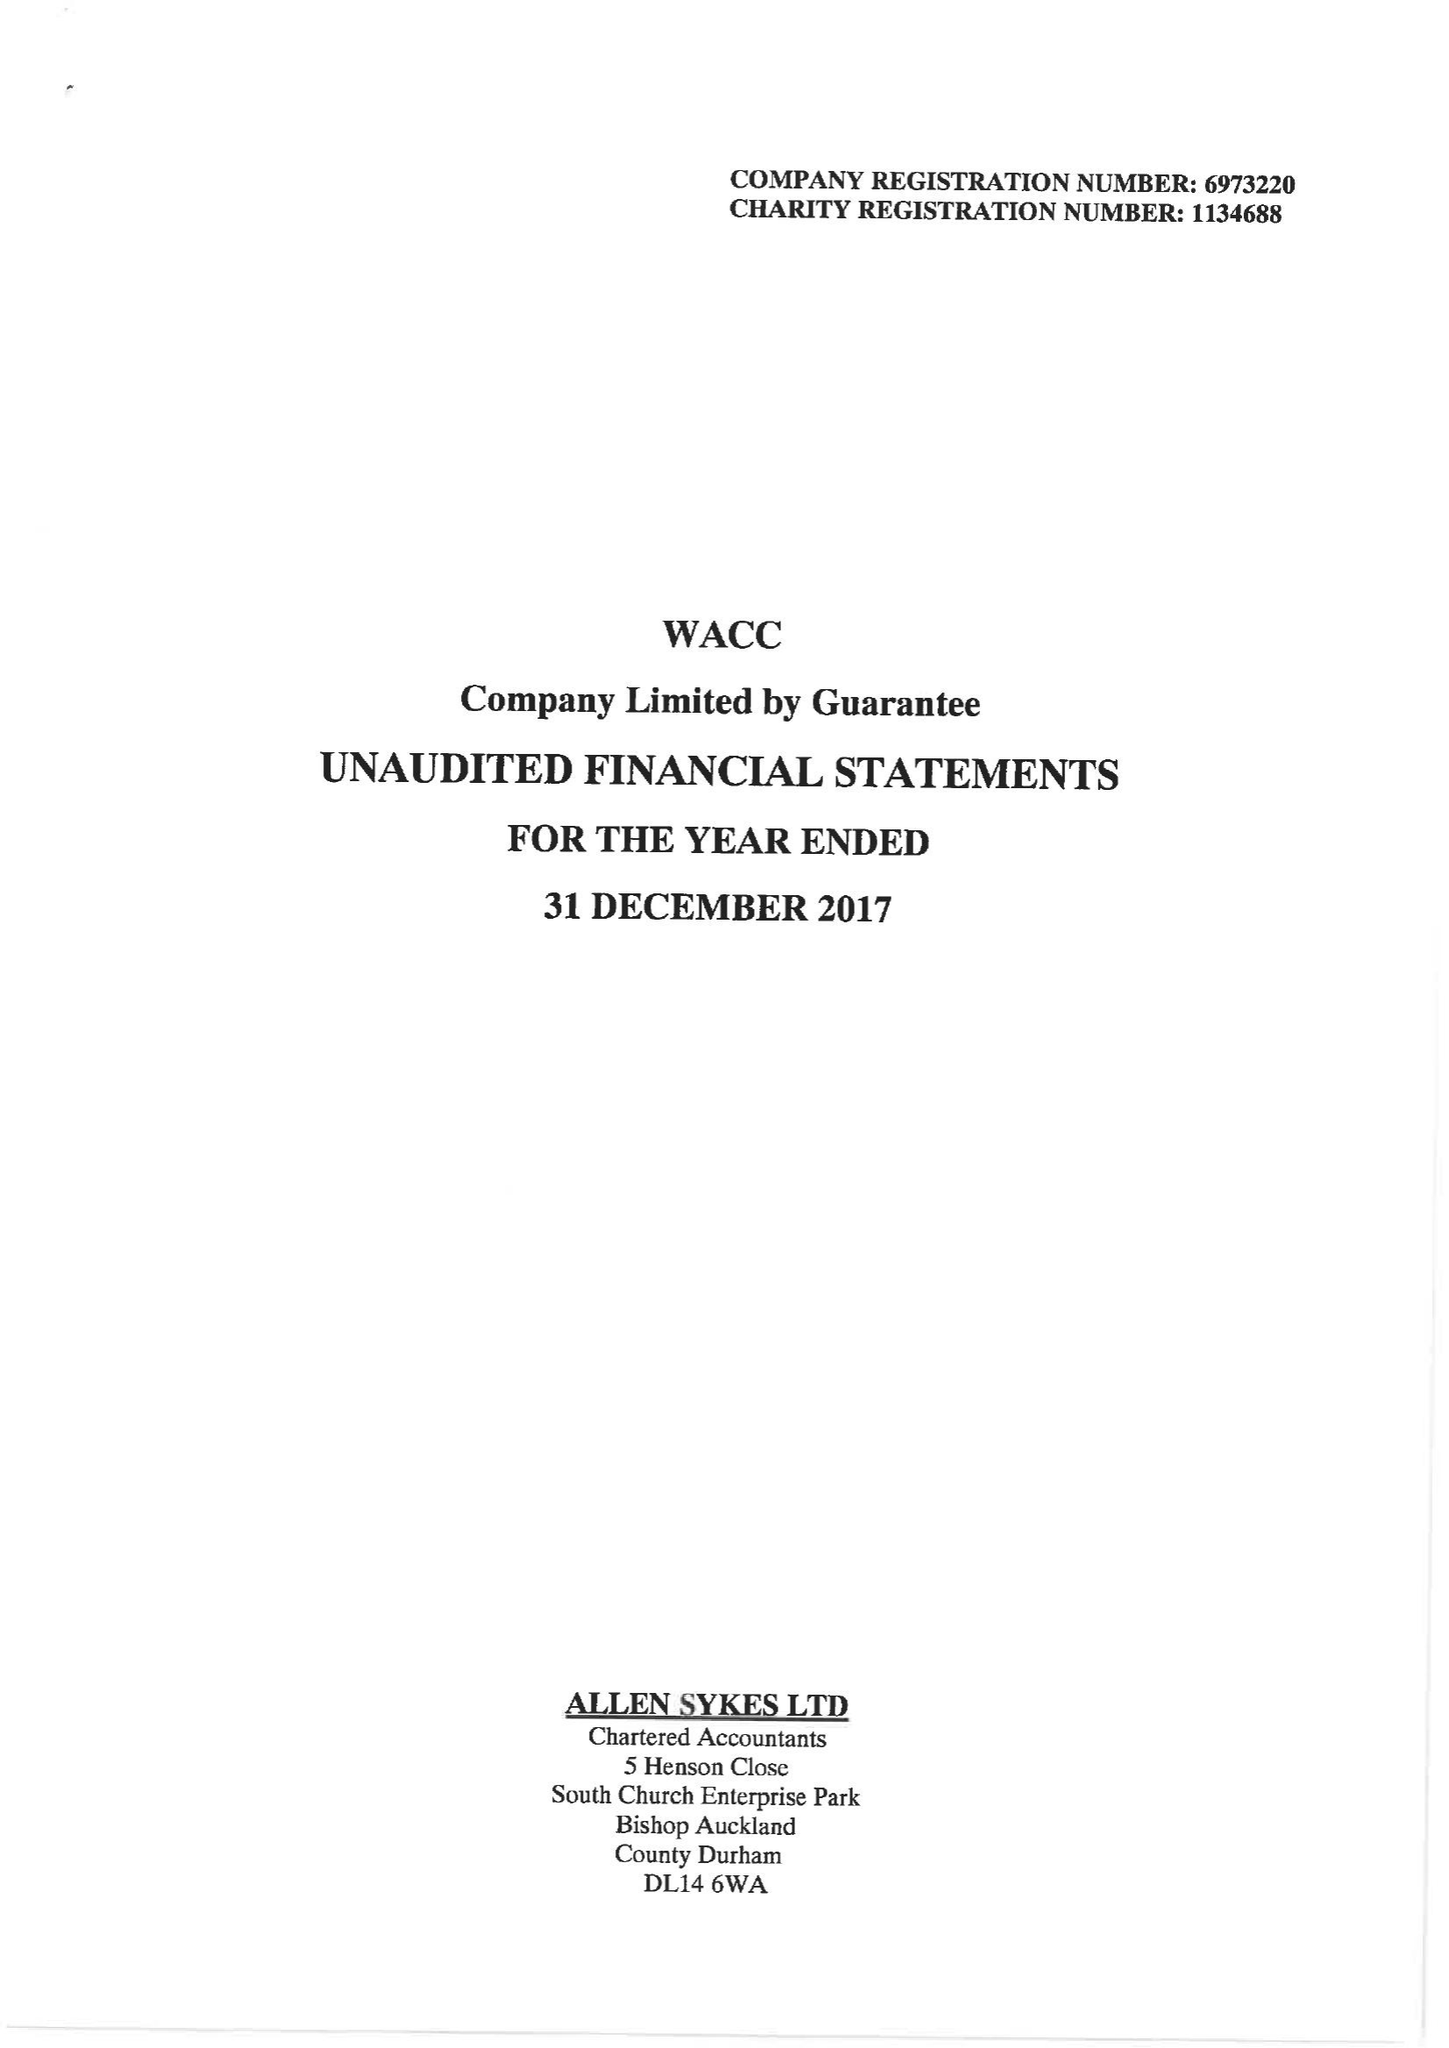What is the value for the address__postcode?
Answer the question using a single word or phrase. DL14 9HJ 